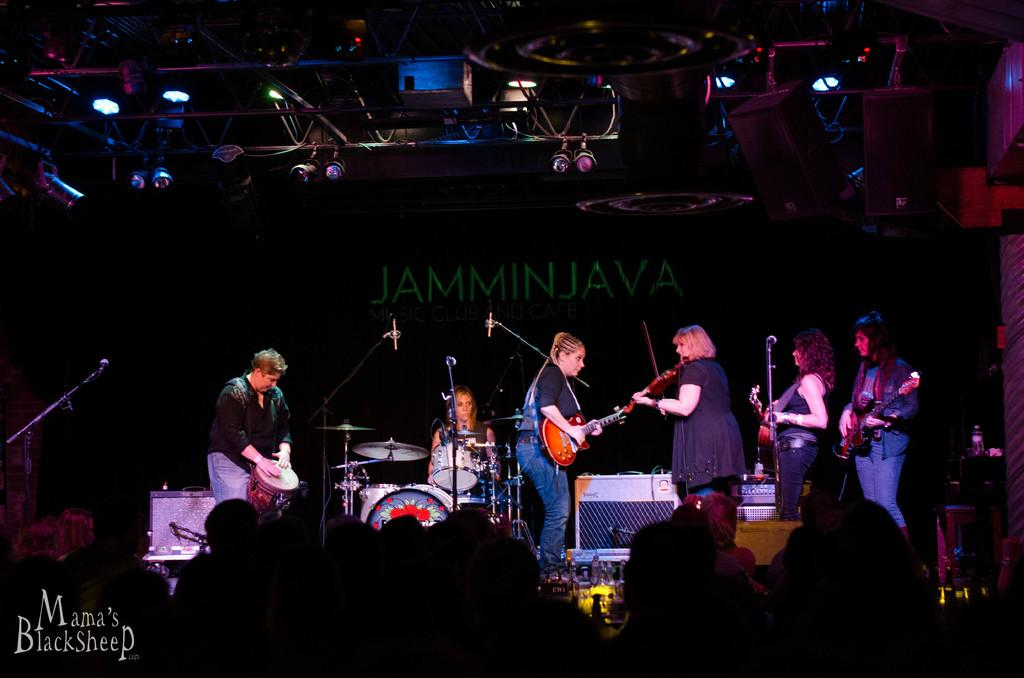What is happening in the image involving the group of people? The people in the image are playing musical instruments. What can be inferred about the musical instruments being played? The musical instruments are of different types. What type of poison is being used by the group of people in the image? There is no mention of poison in the image; the group of people is playing musical instruments. 